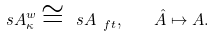<formula> <loc_0><loc_0><loc_500><loc_500>\ s A _ { \kappa } ^ { w } \cong \ s A _ { \ f t } , \quad \hat { A } \mapsto A .</formula> 